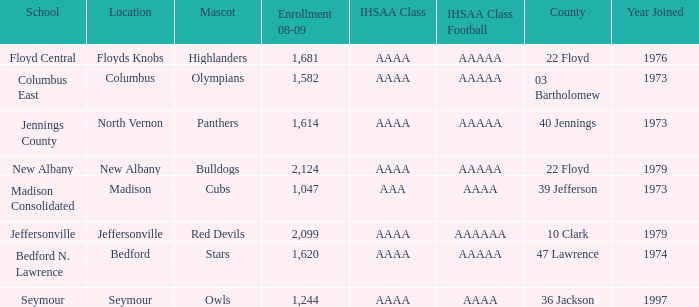What's the IHSAA Class Football if the panthers are the mascot? AAAAA. 